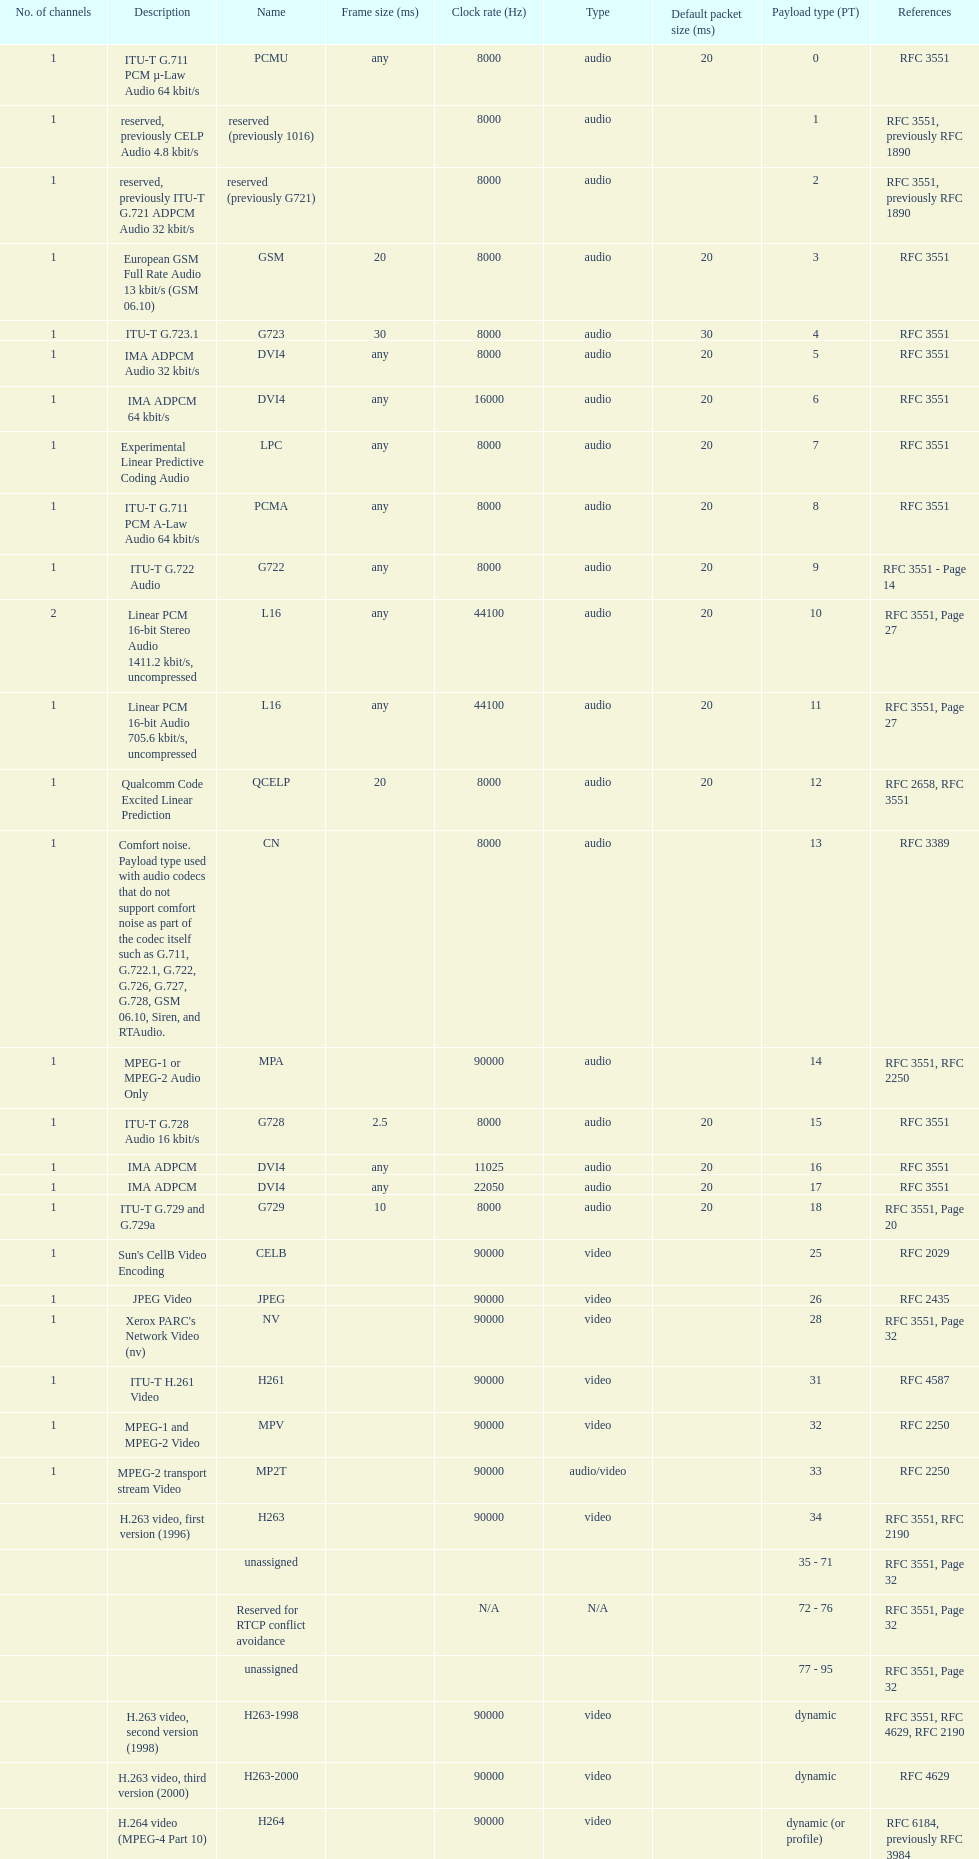Other than audio, what type of payload types are there? Video. 